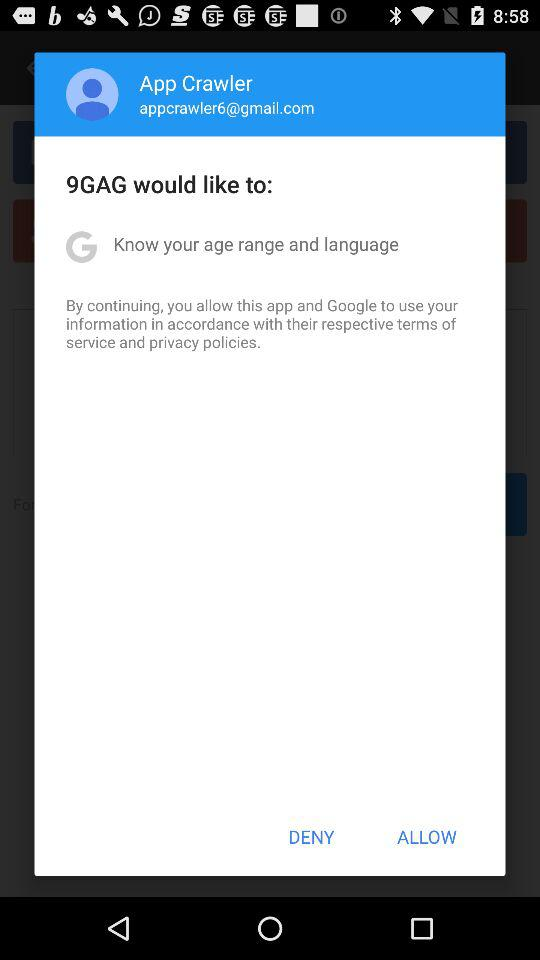What is the email address? The email address is appcrawler6@gmail.com. 